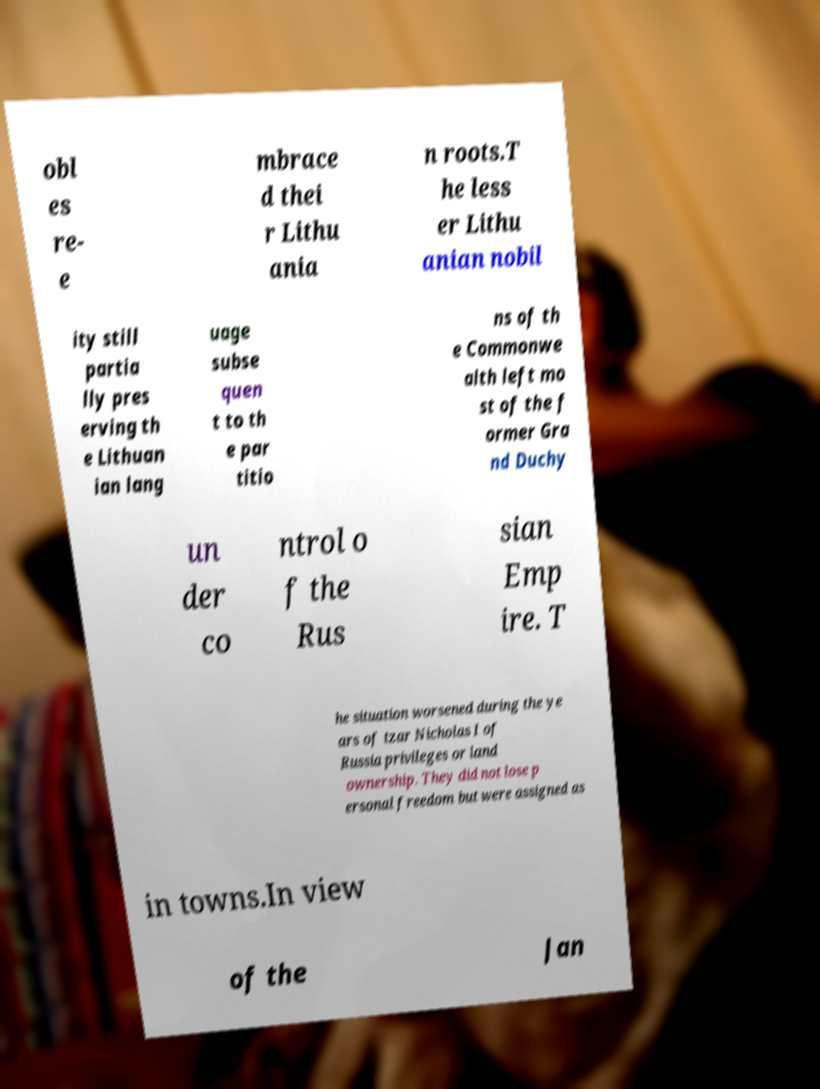What messages or text are displayed in this image? I need them in a readable, typed format. obl es re- e mbrace d thei r Lithu ania n roots.T he less er Lithu anian nobil ity still partia lly pres erving th e Lithuan ian lang uage subse quen t to th e par titio ns of th e Commonwe alth left mo st of the f ormer Gra nd Duchy un der co ntrol o f the Rus sian Emp ire. T he situation worsened during the ye ars of tzar Nicholas I of Russia privileges or land ownership. They did not lose p ersonal freedom but were assigned as in towns.In view of the Jan 